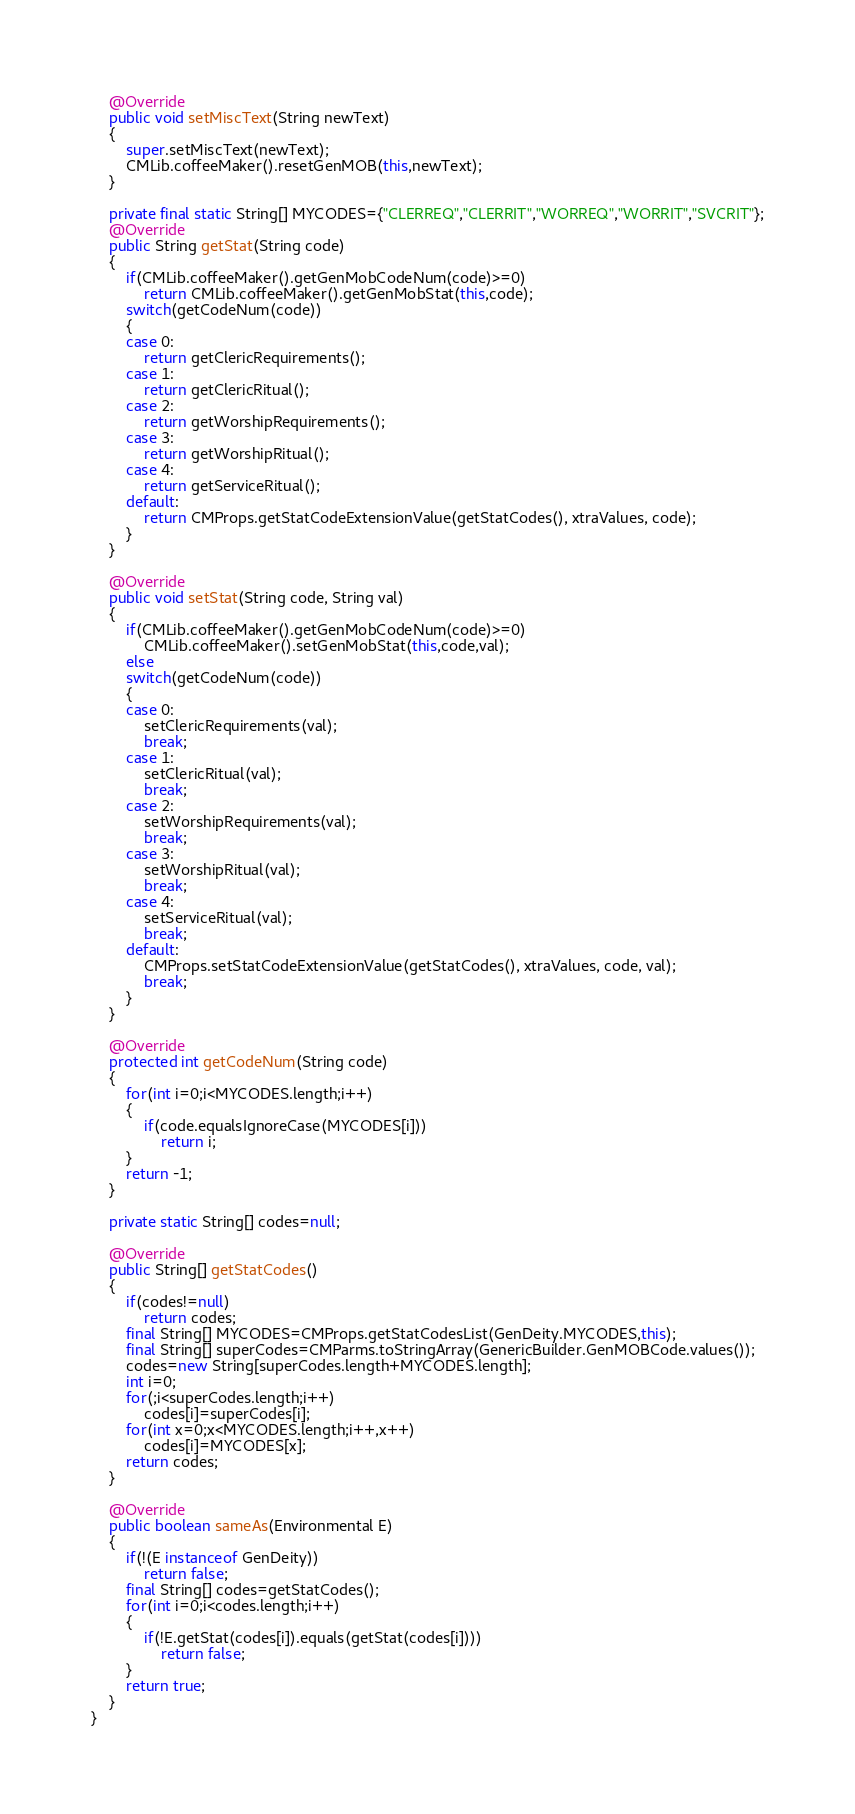Convert code to text. <code><loc_0><loc_0><loc_500><loc_500><_Java_>	@Override
	public void setMiscText(String newText)
	{
		super.setMiscText(newText);
		CMLib.coffeeMaker().resetGenMOB(this,newText);
	}

	private final static String[] MYCODES={"CLERREQ","CLERRIT","WORREQ","WORRIT","SVCRIT"};
	@Override
	public String getStat(String code)
	{
		if(CMLib.coffeeMaker().getGenMobCodeNum(code)>=0)
			return CMLib.coffeeMaker().getGenMobStat(this,code);
		switch(getCodeNum(code))
		{
		case 0:
			return getClericRequirements();
		case 1:
			return getClericRitual();
		case 2:
			return getWorshipRequirements();
		case 3:
			return getWorshipRitual();
		case 4:
			return getServiceRitual();
		default:
			return CMProps.getStatCodeExtensionValue(getStatCodes(), xtraValues, code);
		}
	}

	@Override
	public void setStat(String code, String val)
	{
		if(CMLib.coffeeMaker().getGenMobCodeNum(code)>=0)
			CMLib.coffeeMaker().setGenMobStat(this,code,val);
		else
		switch(getCodeNum(code))
		{
		case 0:
			setClericRequirements(val);
			break;
		case 1:
			setClericRitual(val);
			break;
		case 2:
			setWorshipRequirements(val);
			break;
		case 3:
			setWorshipRitual(val);
			break;
		case 4:
			setServiceRitual(val);
			break;
		default:
			CMProps.setStatCodeExtensionValue(getStatCodes(), xtraValues, code, val);
			break;
		}
	}

	@Override
	protected int getCodeNum(String code)
	{
		for(int i=0;i<MYCODES.length;i++)
		{
			if(code.equalsIgnoreCase(MYCODES[i]))
				return i;
		}
		return -1;
	}

	private static String[] codes=null;

	@Override
	public String[] getStatCodes()
	{
		if(codes!=null)
			return codes;
		final String[] MYCODES=CMProps.getStatCodesList(GenDeity.MYCODES,this);
		final String[] superCodes=CMParms.toStringArray(GenericBuilder.GenMOBCode.values());
		codes=new String[superCodes.length+MYCODES.length];
		int i=0;
		for(;i<superCodes.length;i++)
			codes[i]=superCodes[i];
		for(int x=0;x<MYCODES.length;i++,x++)
			codes[i]=MYCODES[x];
		return codes;
	}

	@Override
	public boolean sameAs(Environmental E)
	{
		if(!(E instanceof GenDeity))
			return false;
		final String[] codes=getStatCodes();
		for(int i=0;i<codes.length;i++)
		{
			if(!E.getStat(codes[i]).equals(getStat(codes[i])))
				return false;
		}
		return true;
	}
}
</code> 